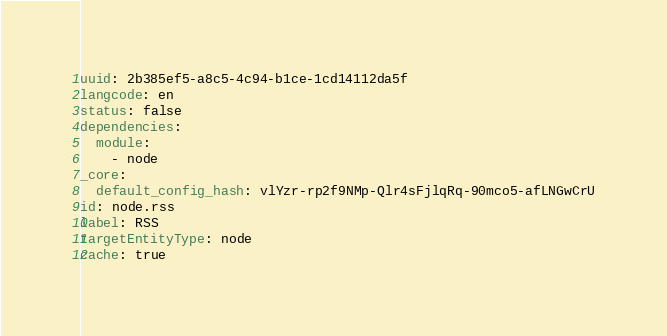Convert code to text. <code><loc_0><loc_0><loc_500><loc_500><_YAML_>uuid: 2b385ef5-a8c5-4c94-b1ce-1cd14112da5f
langcode: en
status: false
dependencies:
  module:
    - node
_core:
  default_config_hash: vlYzr-rp2f9NMp-Qlr4sFjlqRq-90mco5-afLNGwCrU
id: node.rss
label: RSS
targetEntityType: node
cache: true
</code> 